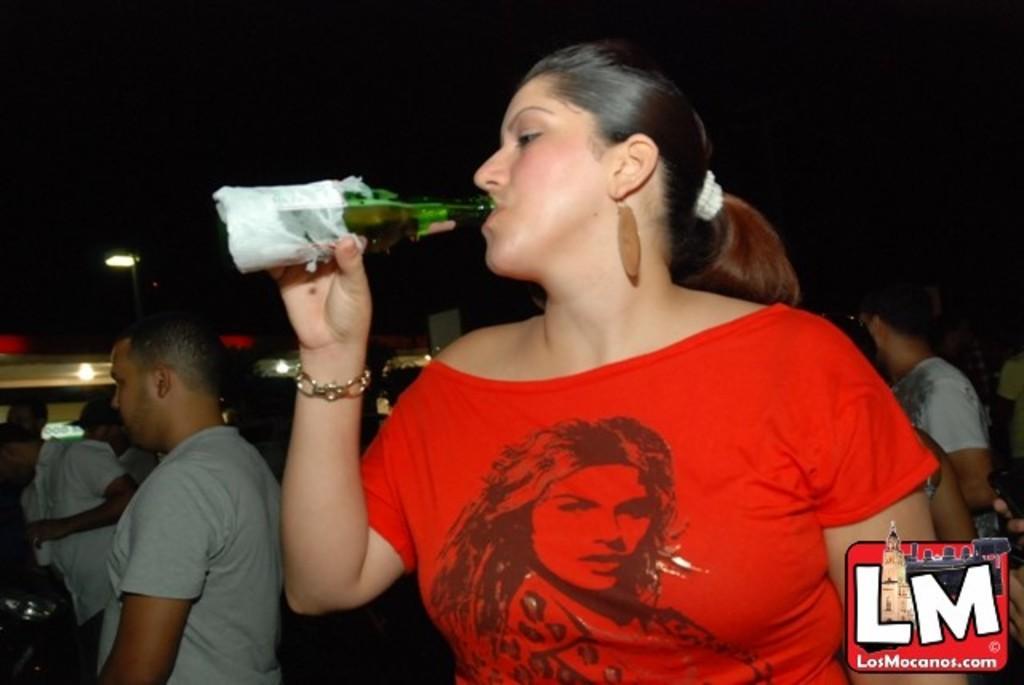Could you give a brief overview of what you see in this image? In this picture I can observe a woman drinking, holding a bottle in her hand. She is wearing red color dress. In the background there are some people standing. On the bottom right side I can observe a watermark. The background is dark. 